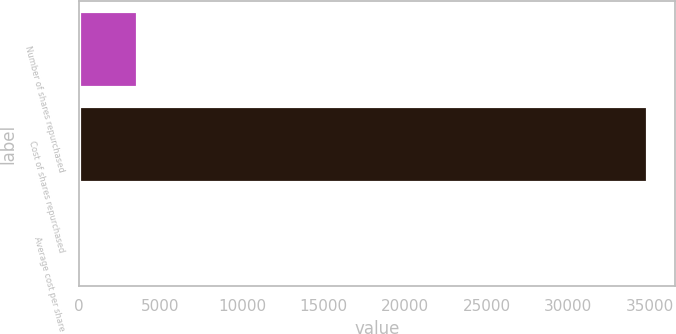Convert chart to OTSL. <chart><loc_0><loc_0><loc_500><loc_500><bar_chart><fcel>Number of shares repurchased<fcel>Cost of shares repurchased<fcel>Average cost per share<nl><fcel>3564.36<fcel>34811<fcel>92.51<nl></chart> 